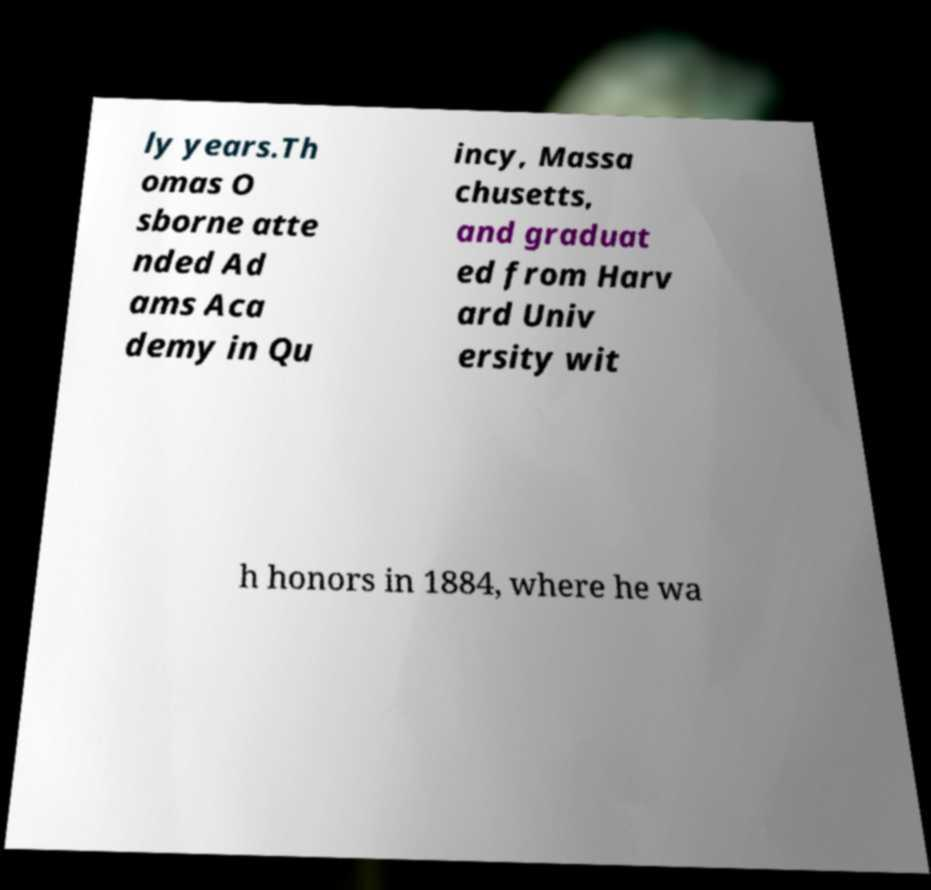For documentation purposes, I need the text within this image transcribed. Could you provide that? ly years.Th omas O sborne atte nded Ad ams Aca demy in Qu incy, Massa chusetts, and graduat ed from Harv ard Univ ersity wit h honors in 1884, where he wa 